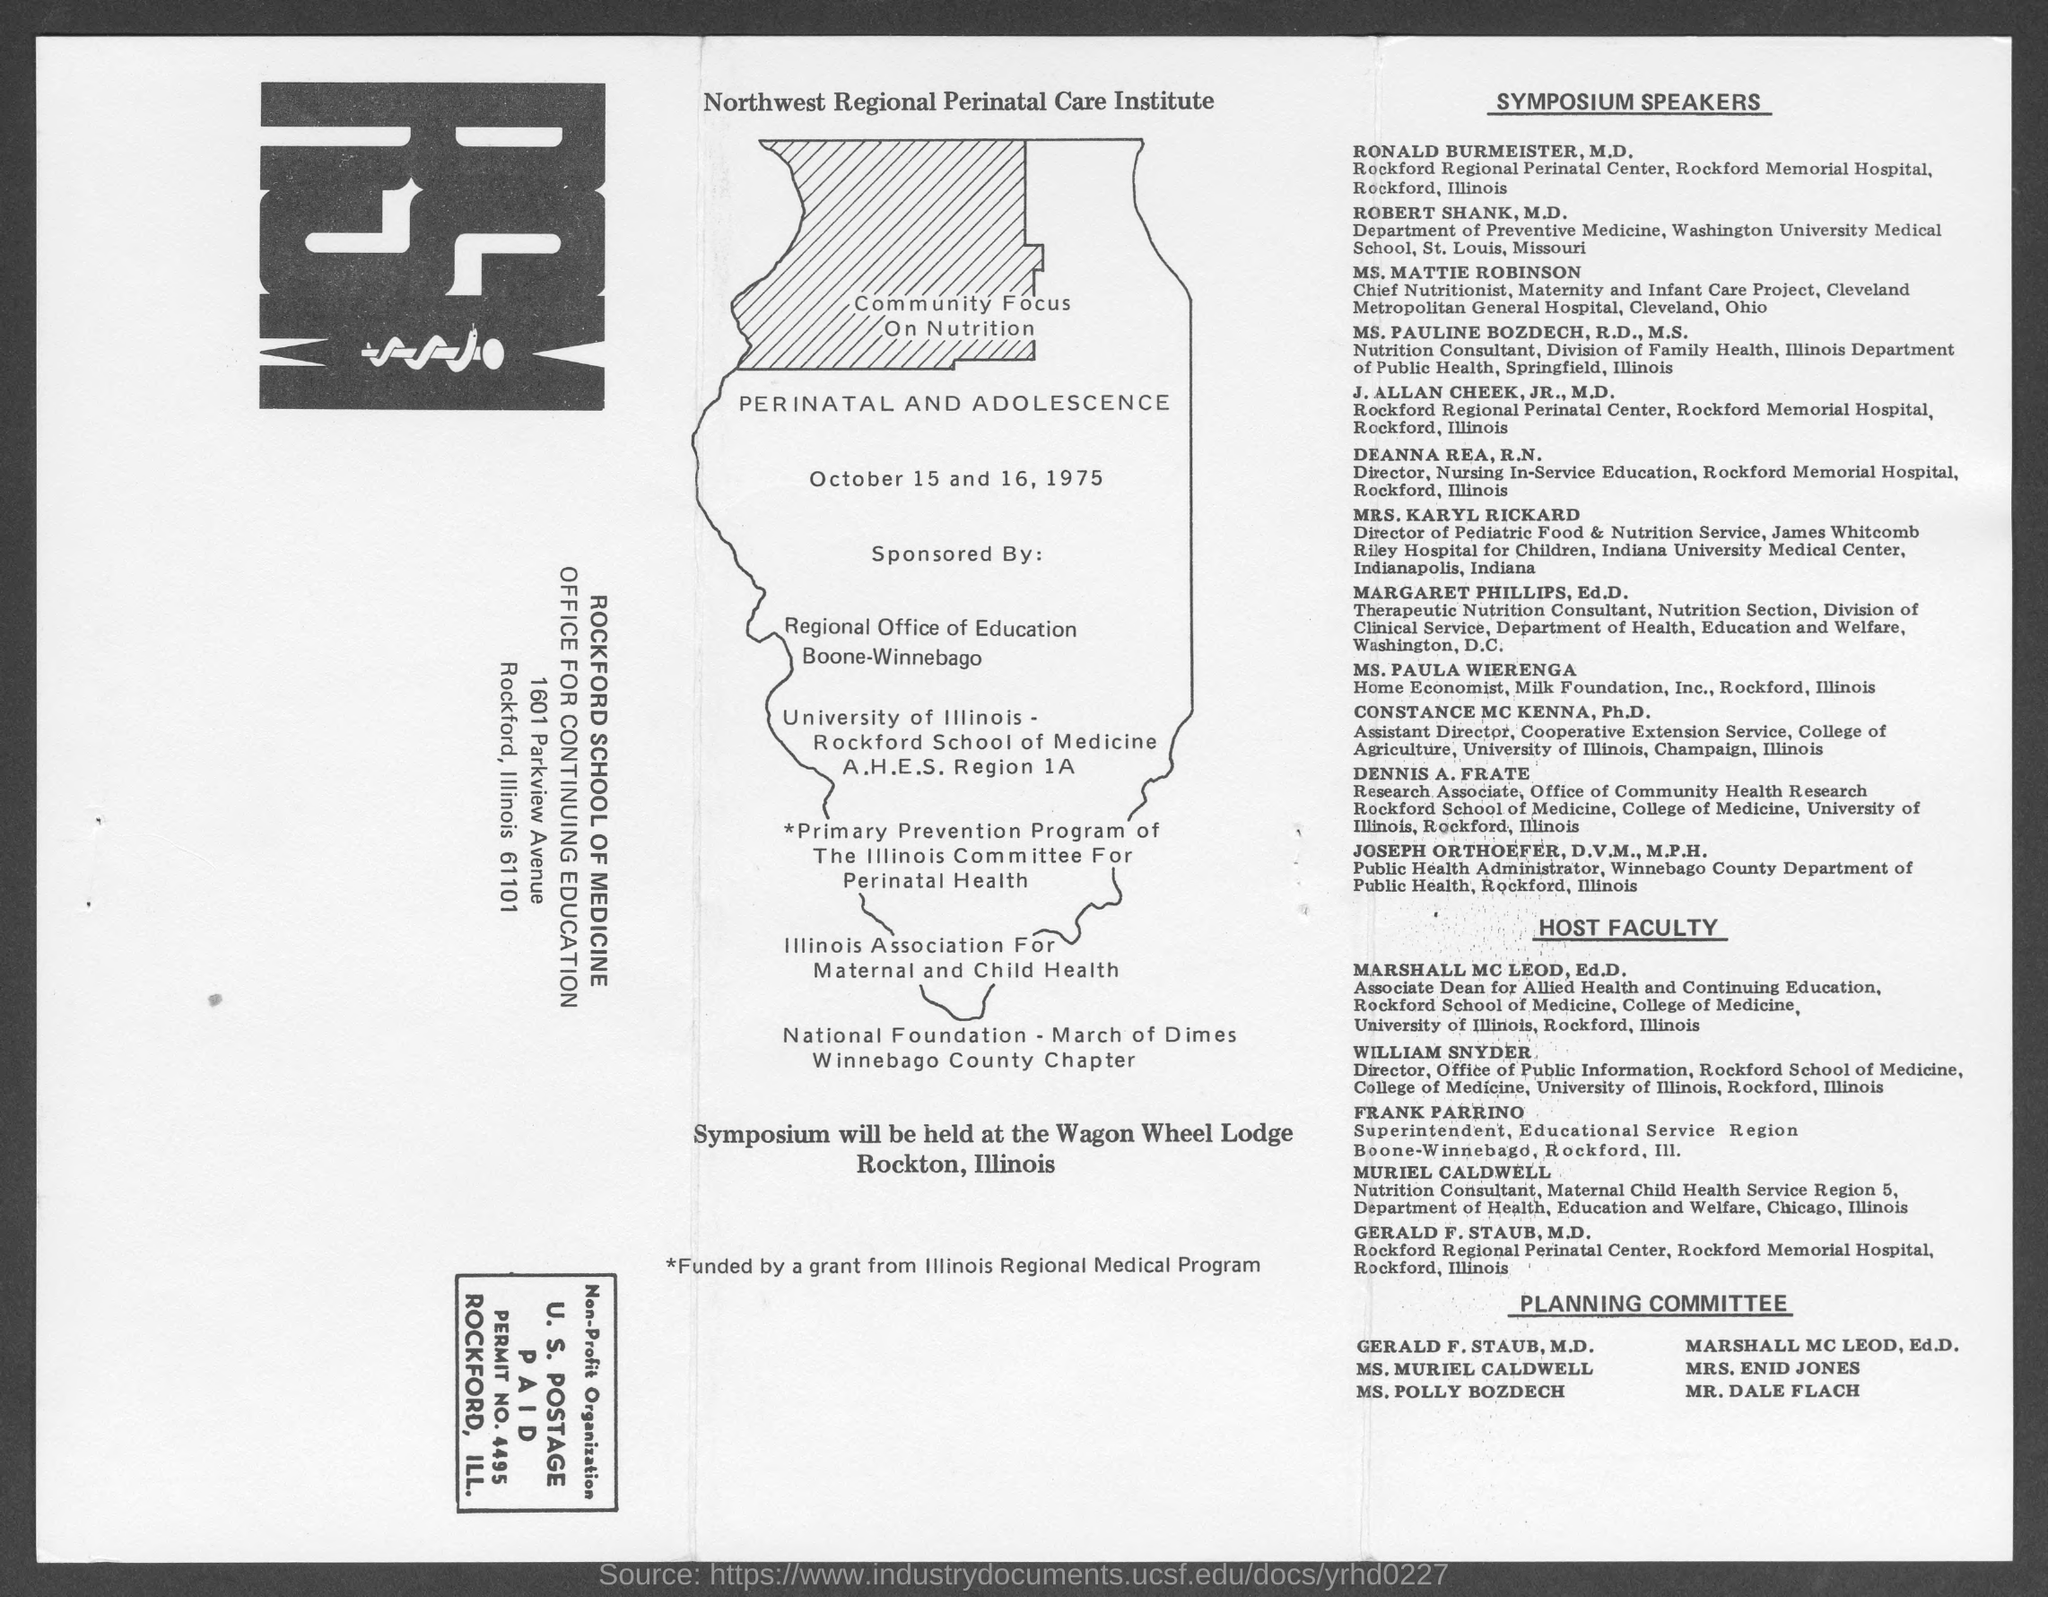What are the dates for the community focus on nutrition  program
Your response must be concise. October 15 and 16 ,1975. Who is the associate dean for allied  health and continuing education
Offer a terse response. MARSHALL MC LEOD. Who is the director, office of public information
Offer a terse response. William Snyder. 